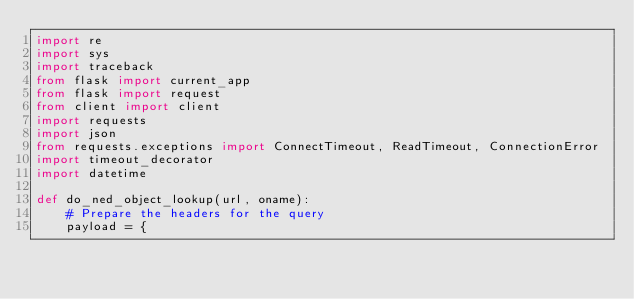Convert code to text. <code><loc_0><loc_0><loc_500><loc_500><_Python_>import re
import sys
import traceback
from flask import current_app
from flask import request
from client import client
import requests
import json
from requests.exceptions import ConnectTimeout, ReadTimeout, ConnectionError
import timeout_decorator
import datetime

def do_ned_object_lookup(url, oname):
    # Prepare the headers for the query
    payload = {</code> 